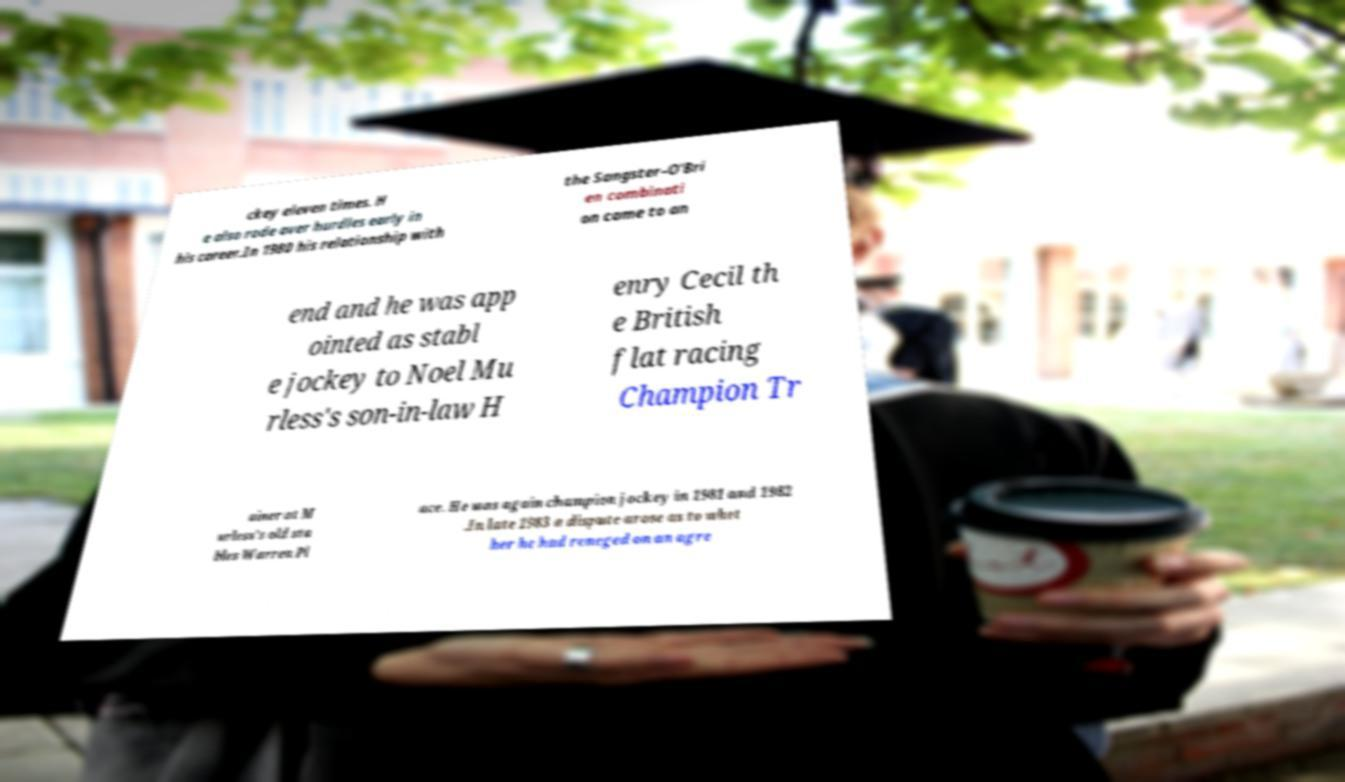Can you accurately transcribe the text from the provided image for me? ckey eleven times. H e also rode over hurdles early in his career.In 1980 his relationship with the Sangster–O'Bri en combinati on came to an end and he was app ointed as stabl e jockey to Noel Mu rless's son-in-law H enry Cecil th e British flat racing Champion Tr ainer at M urless's old sta bles Warren Pl ace. He was again champion jockey in 1981 and 1982 .In late 1983 a dispute arose as to whet her he had reneged on an agre 